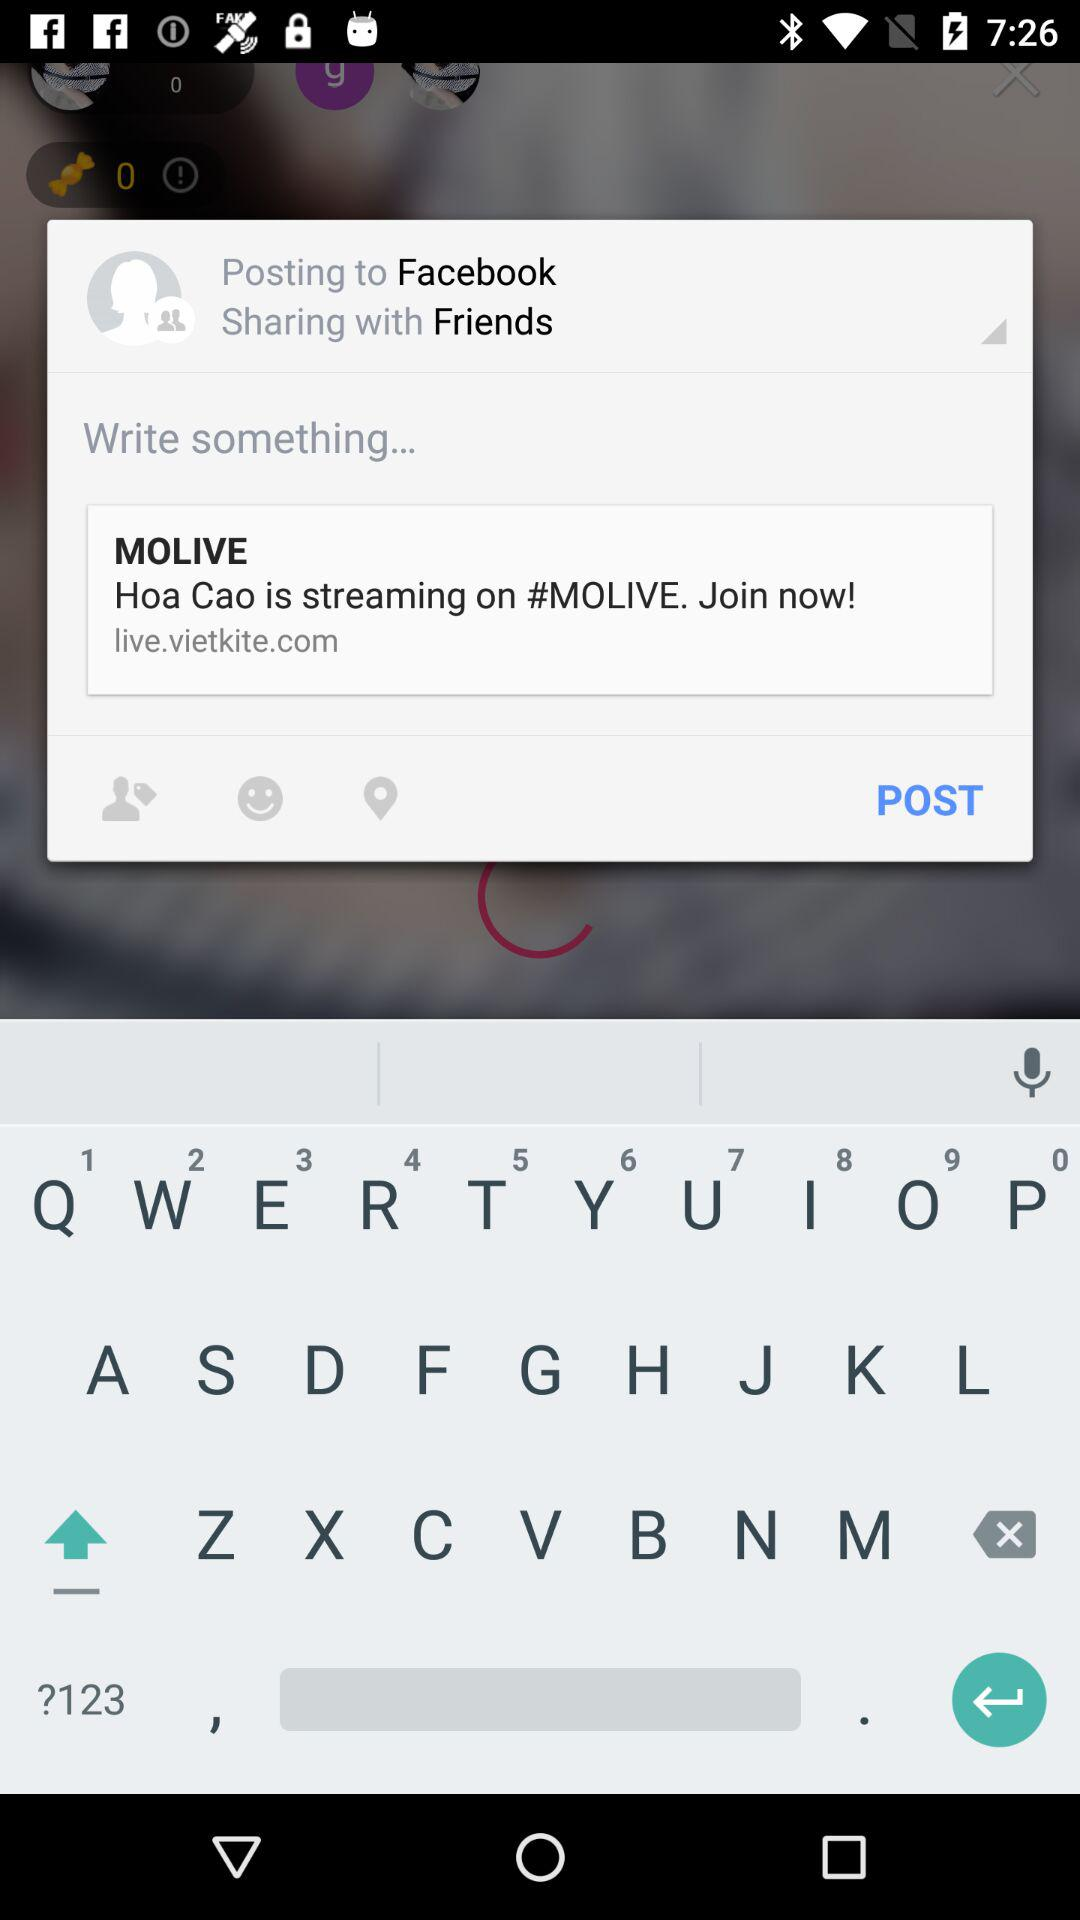When did "John" last log in?
When the provided information is insufficient, respond with <no answer>. <no answer> 